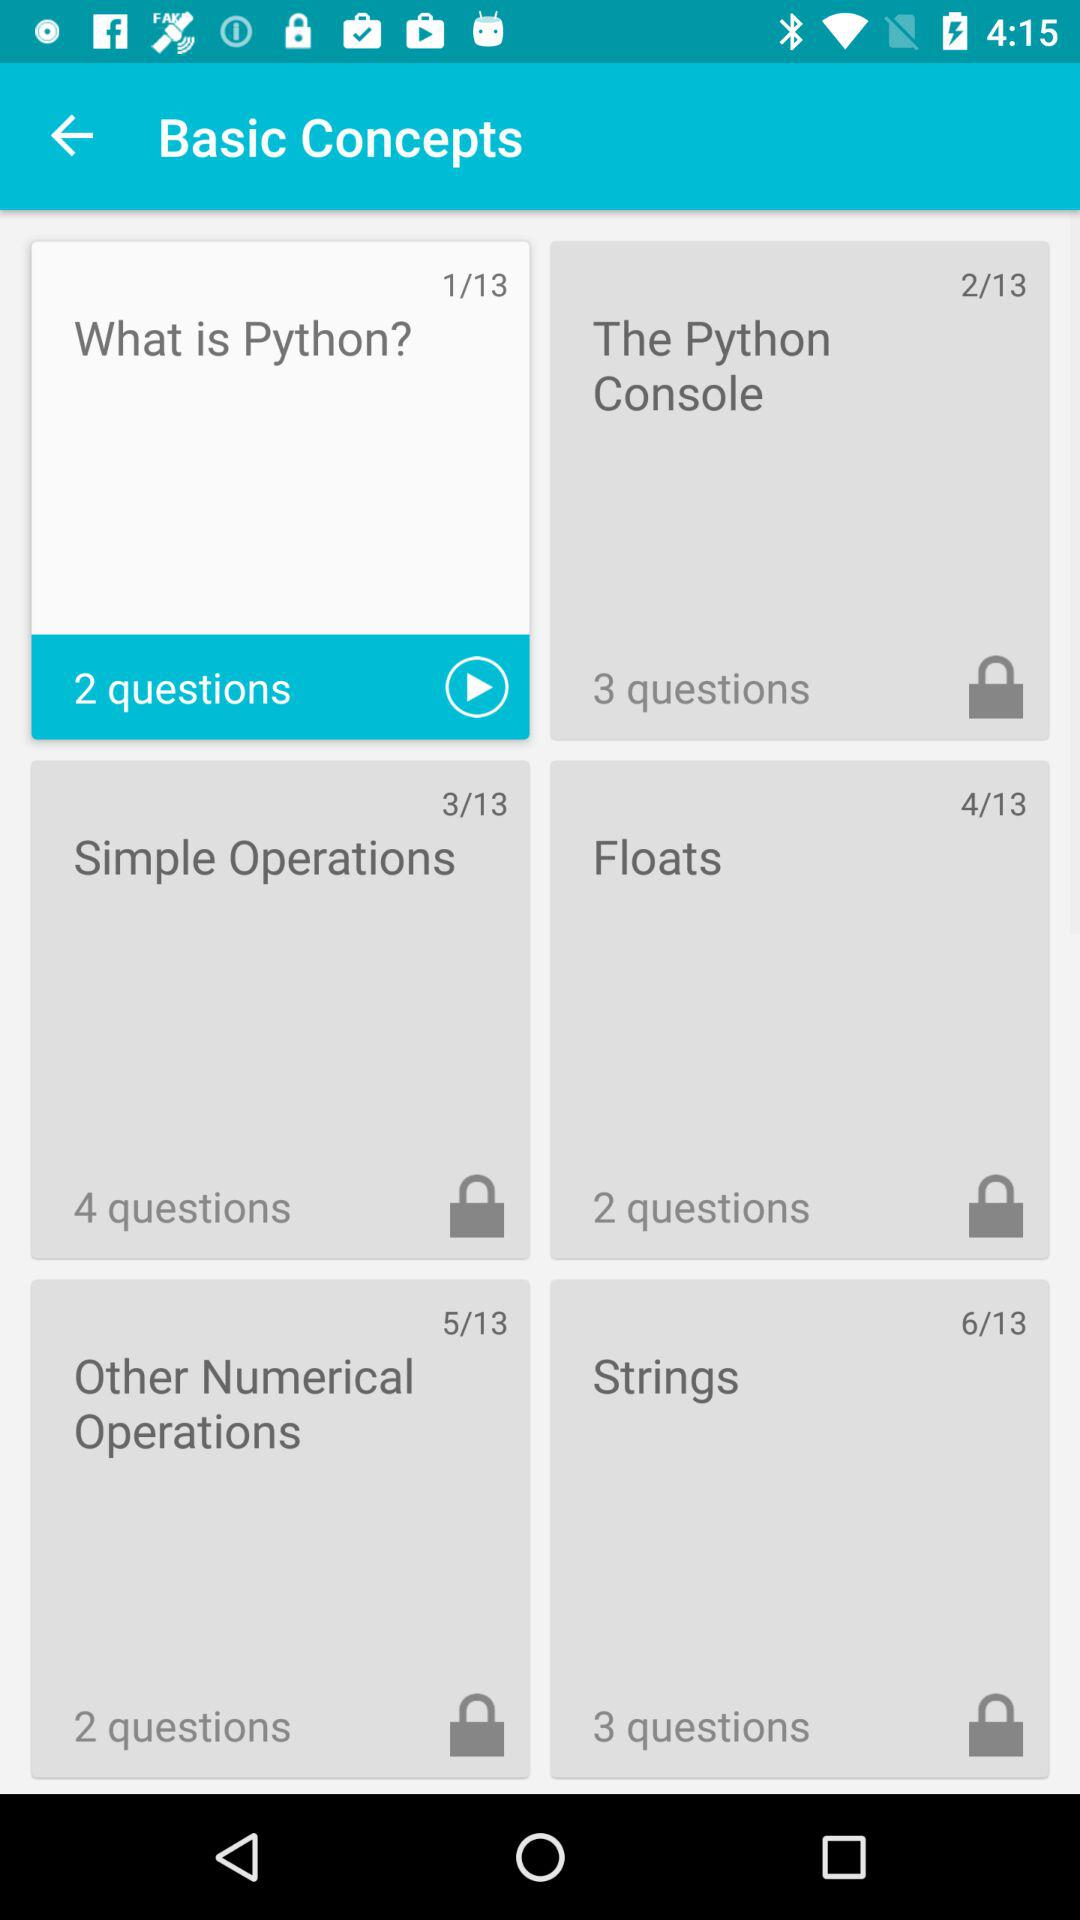How many questions are there in the selected slide? There are 2 questions in the selected slide. 